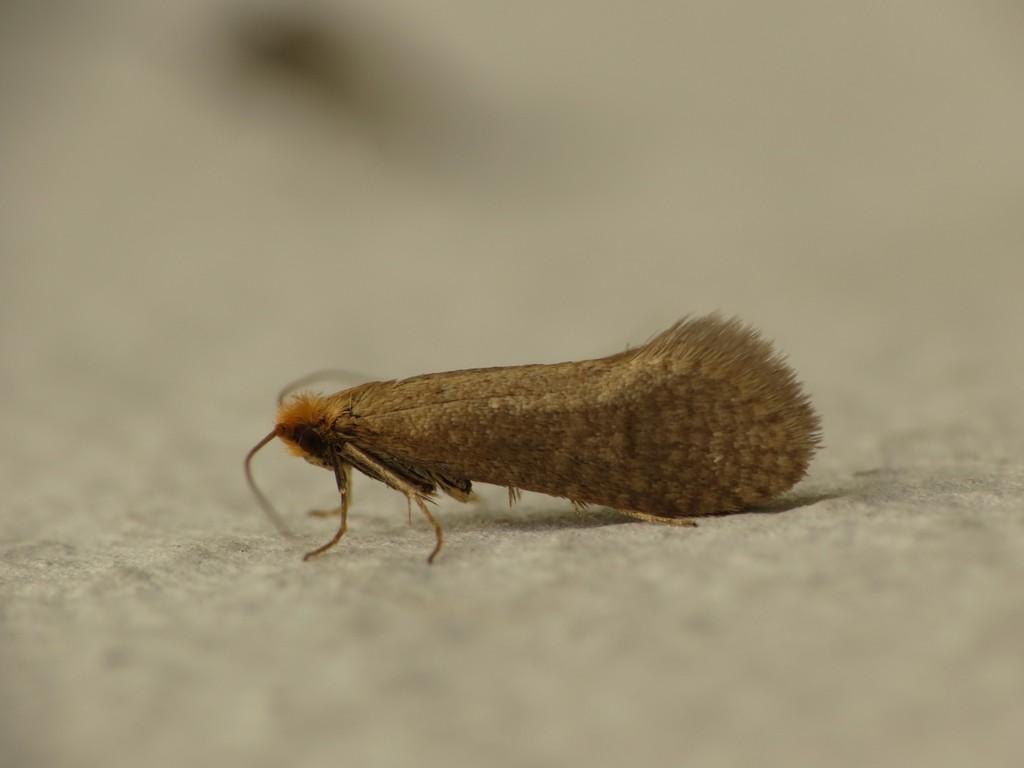What is the main subject of the image? There is an insect in the center of the image. What type of scene is depicted in the image? There is no scene depicted in the image; it only features an insect in the center. How does the acoustics of the image contribute to the overall experience? There is no information about the acoustics of the image, as it only contains a visual representation of an insect. 